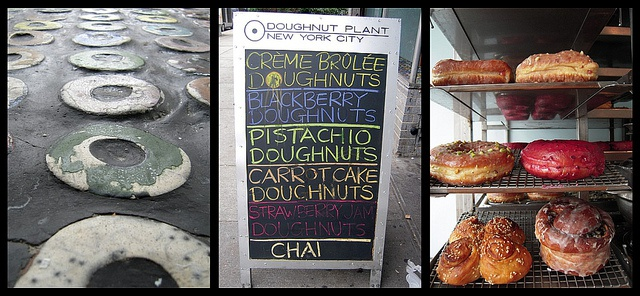Describe the objects in this image and their specific colors. I can see donut in black, maroon, and brown tones, donut in black, brown, maroon, and tan tones, donut in black, maroon, brown, and salmon tones, donut in black, tan, salmon, and brown tones, and donut in black, brown, maroon, and tan tones in this image. 